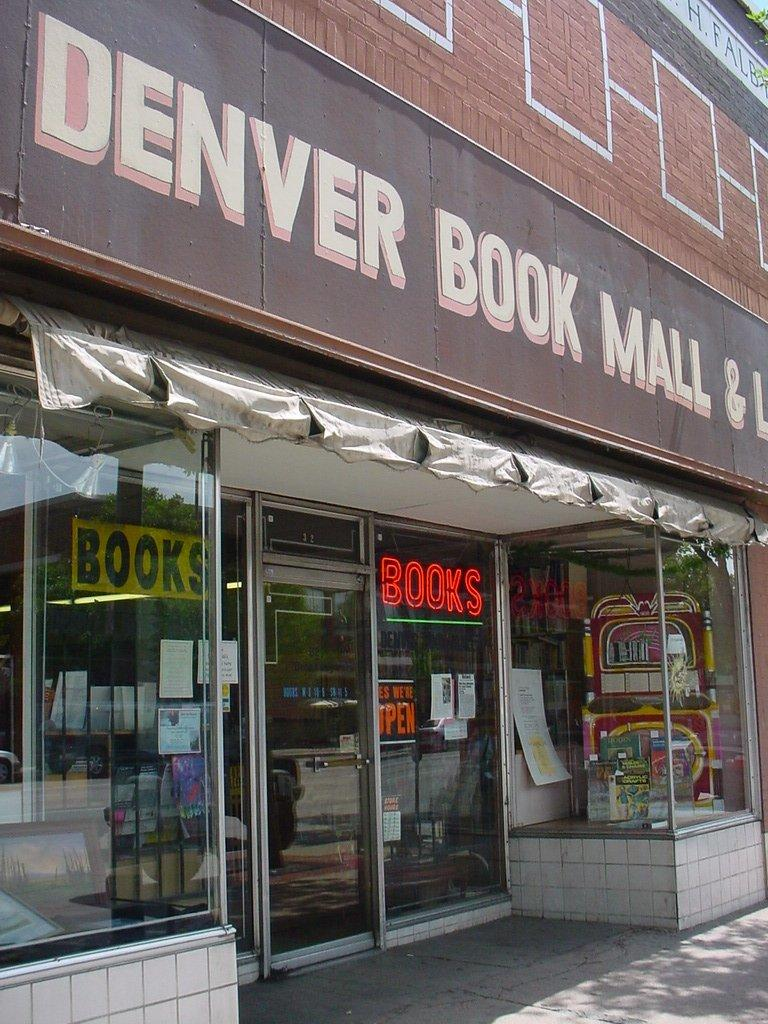<image>
Share a concise interpretation of the image provided. a store front with the store name starting with Denver Book Mall 